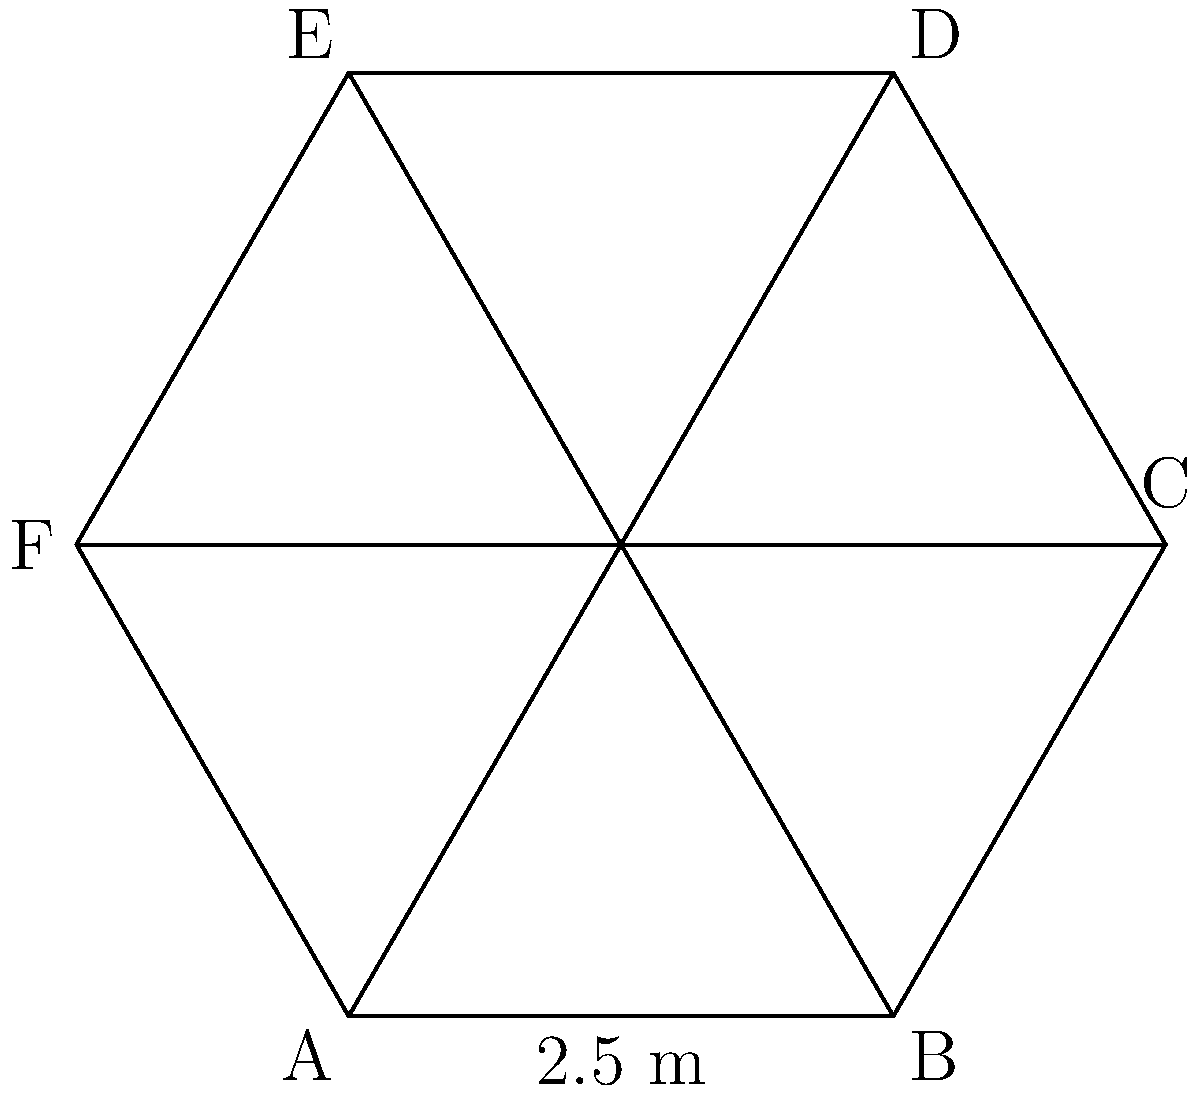Your startup is planning to purchase a hexagonal conference table for your new office space. The table's side length is 2.5 meters. Calculate the perimeter of the table to ensure it fits within the designated area. To calculate the perimeter of a regular hexagon, we need to follow these steps:

1. Recall the formula for the perimeter of a regular polygon:
   $$P = ns$$
   where $P$ is the perimeter, $n$ is the number of sides, and $s$ is the side length.

2. For a hexagon, $n = 6$.

3. We're given that the side length $s = 2.5$ meters.

4. Now, let's substitute these values into the formula:
   $$P = 6 \times 2.5$$

5. Perform the multiplication:
   $$P = 15$$

Therefore, the perimeter of the hexagonal conference table is 15 meters.
Answer: 15 meters 